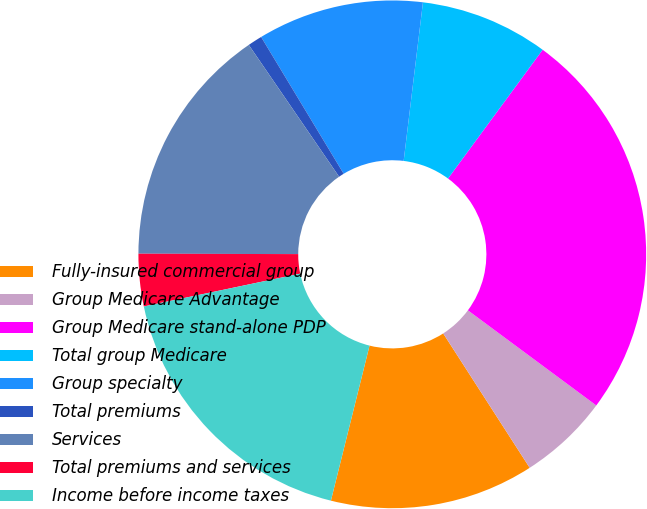<chart> <loc_0><loc_0><loc_500><loc_500><pie_chart><fcel>Fully-insured commercial group<fcel>Group Medicare Advantage<fcel>Group Medicare stand-alone PDP<fcel>Total group Medicare<fcel>Group specialty<fcel>Total premiums<fcel>Services<fcel>Total premiums and services<fcel>Income before income taxes<nl><fcel>12.99%<fcel>5.75%<fcel>25.06%<fcel>8.16%<fcel>10.57%<fcel>0.92%<fcel>15.4%<fcel>3.33%<fcel>17.82%<nl></chart> 